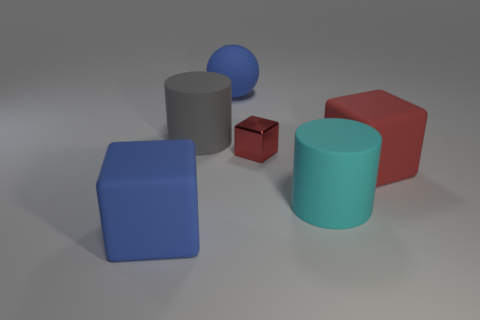The metal thing that is the same shape as the big red rubber object is what size?
Provide a short and direct response. Small. Do the gray rubber thing and the red metal cube have the same size?
Keep it short and to the point. No. Are the large blue block and the red cube on the left side of the cyan object made of the same material?
Make the answer very short. No. There is a cube that is in front of the red rubber cube; is its color the same as the big rubber sphere?
Make the answer very short. Yes. What number of large objects are both on the left side of the large red matte thing and in front of the big gray rubber cylinder?
Provide a succinct answer. 2. How many other objects are the same material as the sphere?
Ensure brevity in your answer.  4. Does the gray cylinder that is to the left of the small red metal object have the same material as the tiny cube?
Ensure brevity in your answer.  No. There is a cyan matte thing that is the same size as the blue ball; what is its shape?
Your answer should be very brief. Cylinder. There is a thing that is on the left side of the cylinder that is to the left of the matte cylinder to the right of the small red block; what is its material?
Provide a short and direct response. Rubber. Is there a red matte cylinder that has the same size as the cyan matte object?
Ensure brevity in your answer.  No. 